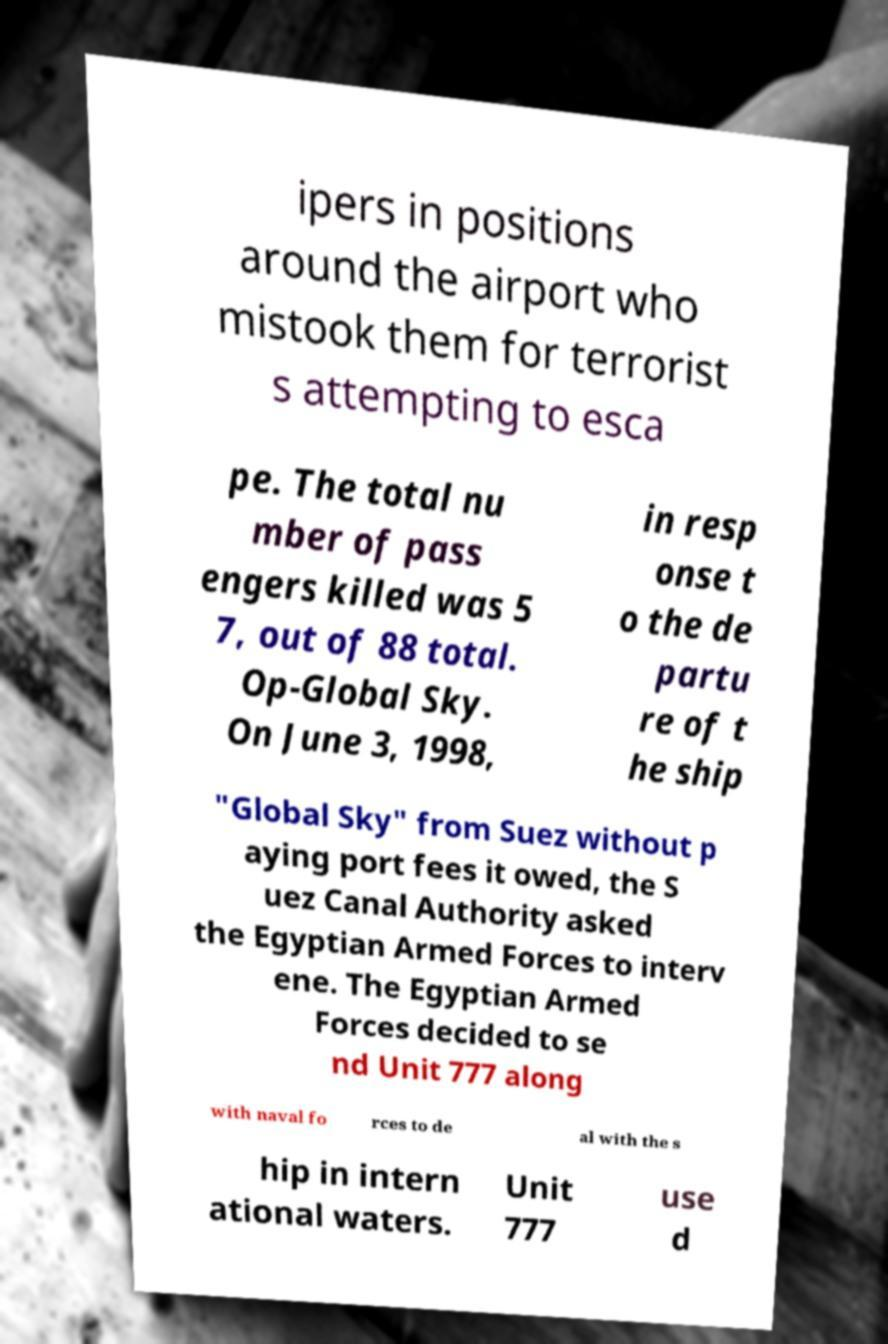Could you extract and type out the text from this image? ipers in positions around the airport who mistook them for terrorist s attempting to esca pe. The total nu mber of pass engers killed was 5 7, out of 88 total. Op-Global Sky. On June 3, 1998, in resp onse t o the de partu re of t he ship "Global Sky" from Suez without p aying port fees it owed, the S uez Canal Authority asked the Egyptian Armed Forces to interv ene. The Egyptian Armed Forces decided to se nd Unit 777 along with naval fo rces to de al with the s hip in intern ational waters. Unit 777 use d 